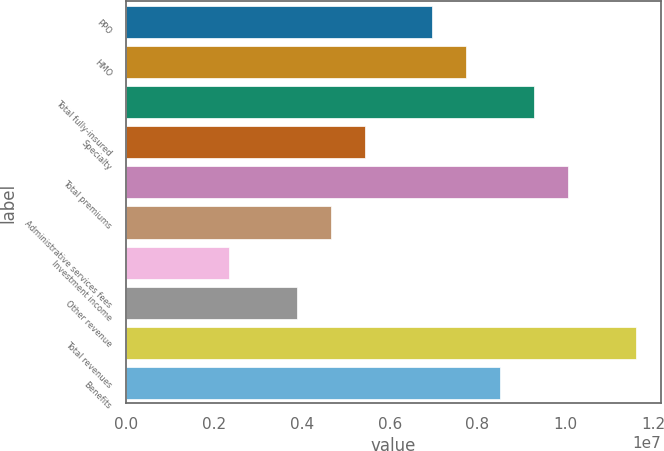Convert chart. <chart><loc_0><loc_0><loc_500><loc_500><bar_chart><fcel>PPO<fcel>HMO<fcel>Total fully-insured<fcel>Specialty<fcel>Total premiums<fcel>Administrative services fees<fcel>Investment income<fcel>Other revenue<fcel>Total revenues<fcel>Benefits<nl><fcel>6.9699e+06<fcel>7.74147e+06<fcel>9.28461e+06<fcel>5.42676e+06<fcel>1.00562e+07<fcel>4.65519e+06<fcel>2.34048e+06<fcel>3.88362e+06<fcel>1.15993e+07<fcel>8.51304e+06<nl></chart> 